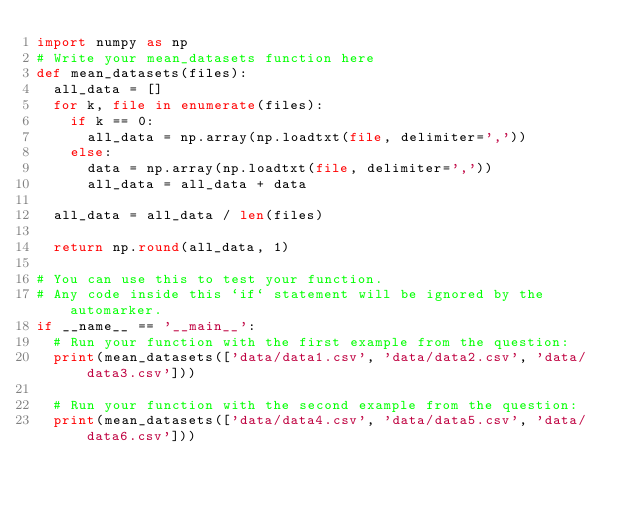<code> <loc_0><loc_0><loc_500><loc_500><_Python_>import numpy as np
# Write your mean_datasets function here
def mean_datasets(files):
  all_data = []
  for k, file in enumerate(files):
    if k == 0:
      all_data = np.array(np.loadtxt(file, delimiter=','))
    else:
      data = np.array(np.loadtxt(file, delimiter=','))
      all_data = all_data + data
      
  all_data = all_data / len(files)
  
  return np.round(all_data, 1)

# You can use this to test your function.
# Any code inside this `if` statement will be ignored by the automarker.
if __name__ == '__main__':
  # Run your function with the first example from the question:
  print(mean_datasets(['data/data1.csv', 'data/data2.csv', 'data/data3.csv']))

  # Run your function with the second example from the question:
  print(mean_datasets(['data/data4.csv', 'data/data5.csv', 'data/data6.csv']))</code> 